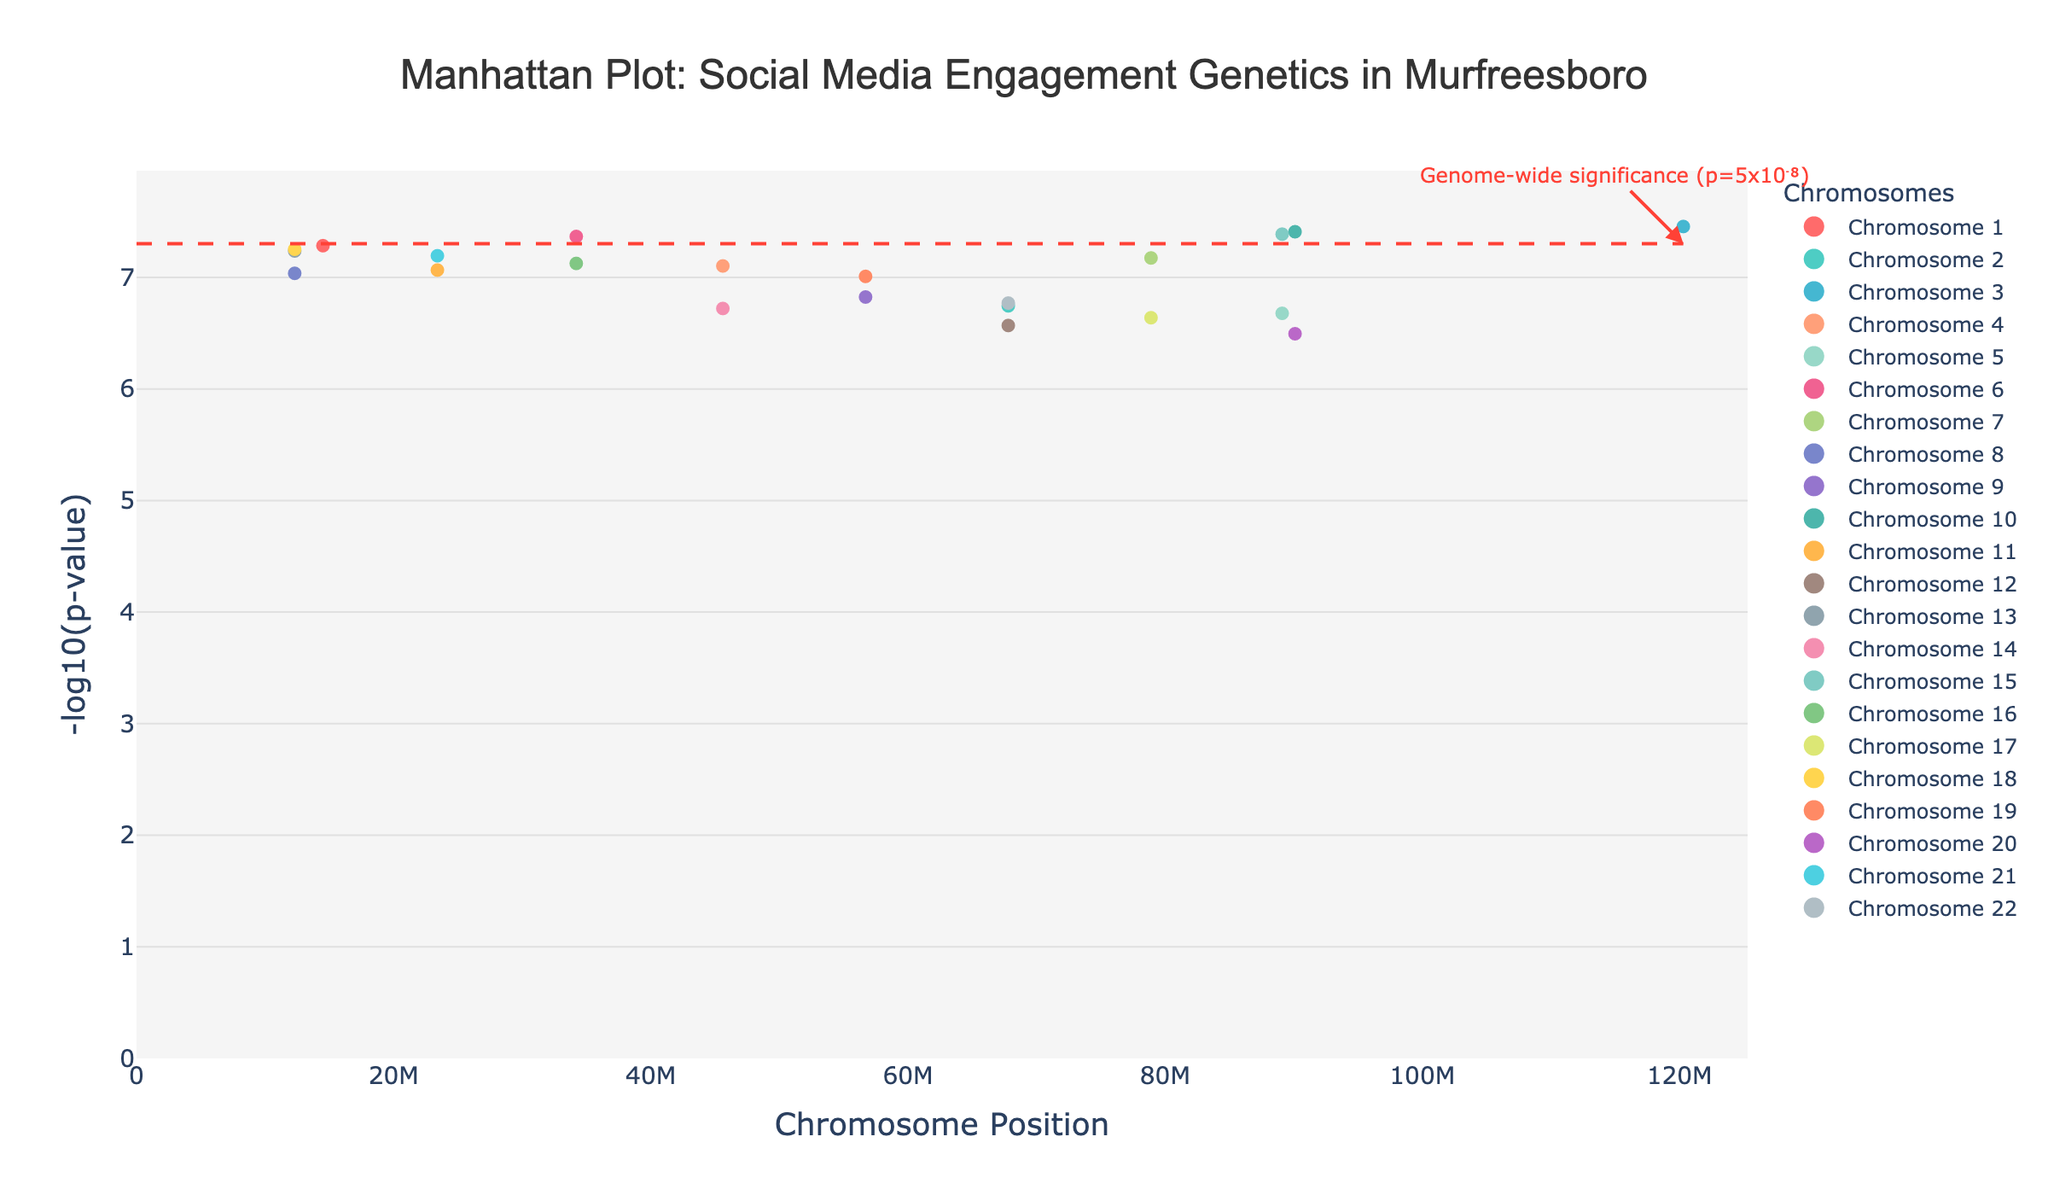What is the title of the plot? The title is displayed at the top of the plot, centered, and in a larger font size. The text reads "Manhattan Plot: Social Media Engagement Genetics in Murfreesboro."
Answer: Manhattan Plot: Social Media Engagement Genetics in Murfreesboro Which chromosome has the most significant SNP? To determine this, look for the SNP with the highest -log10(p-value). The SNP rs1234567 on Chromosome 1 has the highest -log10(p-value) of around 7.3 (since -log10(5.2e-8) ≈ 7.28), making Chromosome 1 the most significant.
Answer: Chromosome 1 How many chromosomes are shown in the plot? The legend on the right of the plot lists each chromosome with its respective color. By counting the items in the legend, we can see there are 22 chromosomes displayed.
Answer: 22 Which SNP lies closest to the genome-wide significance line? The genome-wide significance line is at -log10(p) ≈ 7.3. The closest SNP is rs1234567 on Chromosome 1, which has a -log10(p-value) of approximately 7.3.
Answer: rs1234567 What is the SNP associated with the MTSU1 gene? The hover-over information for the data point lists the SNP names and associated genes. The SNP associated with MTSU1 is rs2345678, which is located on Chromosome 2.
Answer: rs2345678 Which SNP has the highest -log10(p-value) on Chromosome 19? By examining the y-axis values for Chromosome 19 (colored according to the legend), the SNP with the highest -log10(p-value) is rs9900112. This indicates the lowest p-value on Chromosome 19.
Answer: rs9900112 How many SNPs have a -log10(p-value) greater than 7? By visually inspecting the plot and counting the points above the y-value of 7, we can identify there are 5 SNPs with a -log10(p-value) greater than 7.
Answer: 5 Which gene is most significant on Chromosome 10? By evaluating the SNPs on Chromosome 10 (as indicated by the color in the legend), the SNP with the highest -log10(p-value) belongs to gene RDDT1, specifically the SNP rs0123456.
Answer: RDDT1 What is the position range displayed for the SNPs? The x-axis shows the chromosome positions ranging from the lowest to the highest position across all chromosomes. The displayed positions start from 0 up to the maximum SNP position, slightly above 90000000.
Answer: 0 to 90100000 